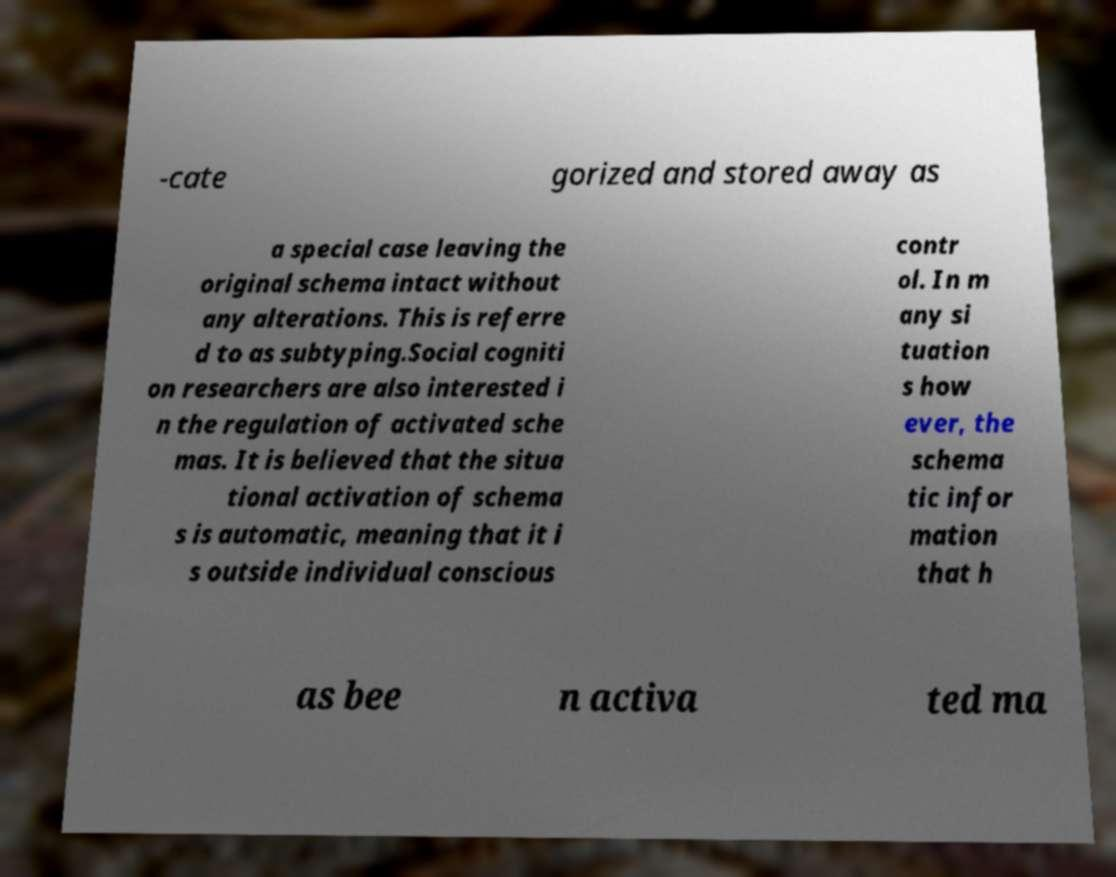Could you extract and type out the text from this image? -cate gorized and stored away as a special case leaving the original schema intact without any alterations. This is referre d to as subtyping.Social cogniti on researchers are also interested i n the regulation of activated sche mas. It is believed that the situa tional activation of schema s is automatic, meaning that it i s outside individual conscious contr ol. In m any si tuation s how ever, the schema tic infor mation that h as bee n activa ted ma 